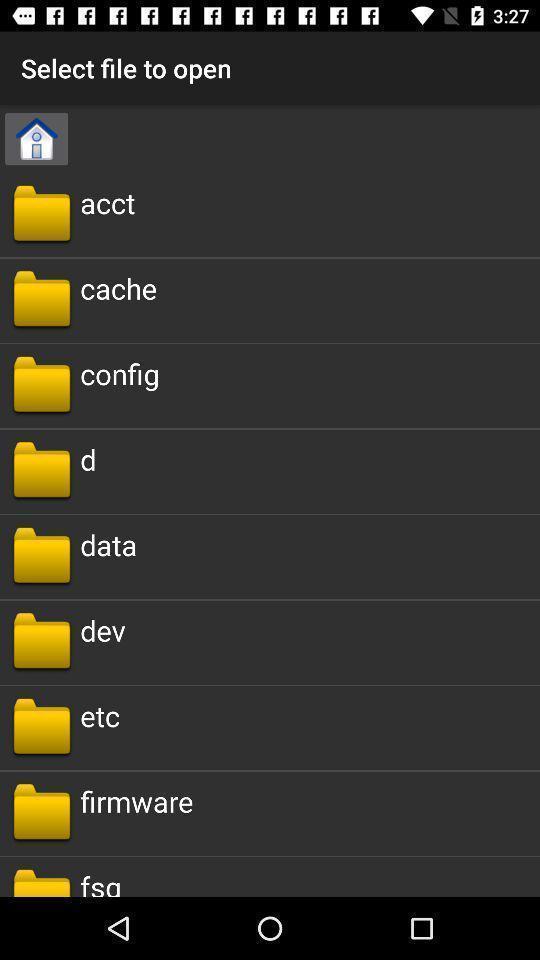Give me a narrative description of this picture. Screen displaying the list of folders. 